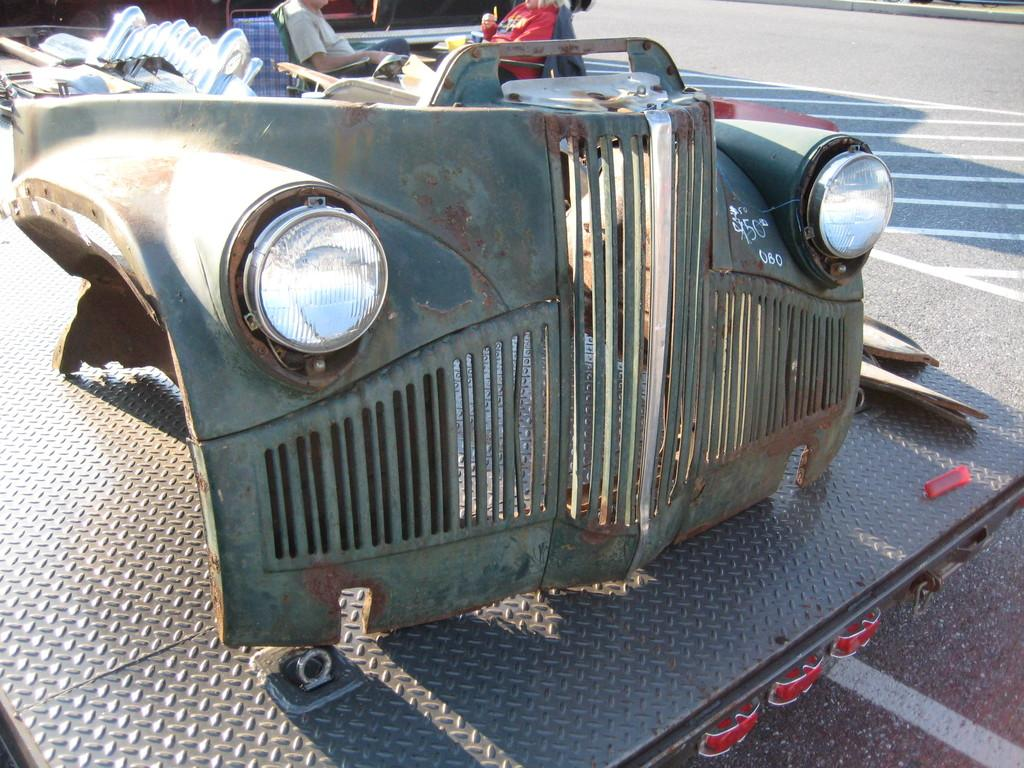What objects related to a car can be seen in the image? There are parts of a car in the image. Where are the car parts located? The car parts are placed on a surface. How many people are in the image? There are two people in the image. What are the people doing in the image? The people are sitting on chairs. Where are the chairs placed? The chairs are placed on the road. What page of a book are the people reading in the image? There is no book or page visible in the image; the people are sitting on chairs with car parts nearby. 